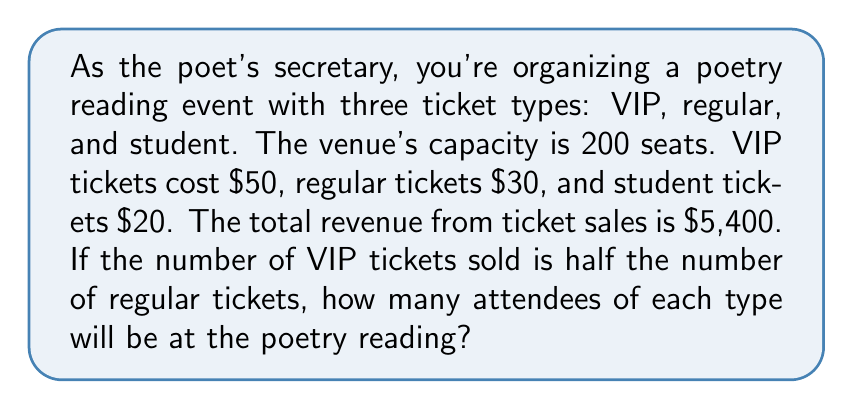Help me with this question. Let's approach this step-by-step using a system of linear equations:

1) Let $x$ be the number of VIP tickets, $y$ be the number of regular tickets, and $z$ be the number of student tickets.

2) Given information:
   - Total capacity: $x + y + z = 200$
   - Revenue equation: $50x + 30y + 20z = 5400$
   - VIP tickets are half of regular tickets: $x = \frac{1}{2}y$

3) Substituting $x = \frac{1}{2}y$ into the other equations:
   $$\frac{1}{2}y + y + z = 200$$
   $$50(\frac{1}{2}y) + 30y + 20z = 5400$$

4) Simplifying:
   $$\frac{3}{2}y + z = 200 \quad (1)$$
   $$25y + 30y + 20z = 5400$$
   $$55y + 20z = 5400 \quad (2)$$

5) Multiply equation (1) by 20:
   $$30y + 20z = 4000 \quad (3)$$

6) Subtract equation (3) from equation (2):
   $$25y = 1400$$
   $$y = 56$$

7) Substitute $y = 56$ into $x = \frac{1}{2}y$:
   $$x = 28$$

8) Substitute $x = 28$ and $y = 56$ into equation (1):
   $$\frac{3}{2}(56) + z = 200$$
   $$84 + z = 200$$
   $$z = 116$$

Therefore, there will be 28 VIP attendees, 56 regular attendees, and 116 student attendees.
Answer: 28 VIP, 56 regular, 116 student attendees 